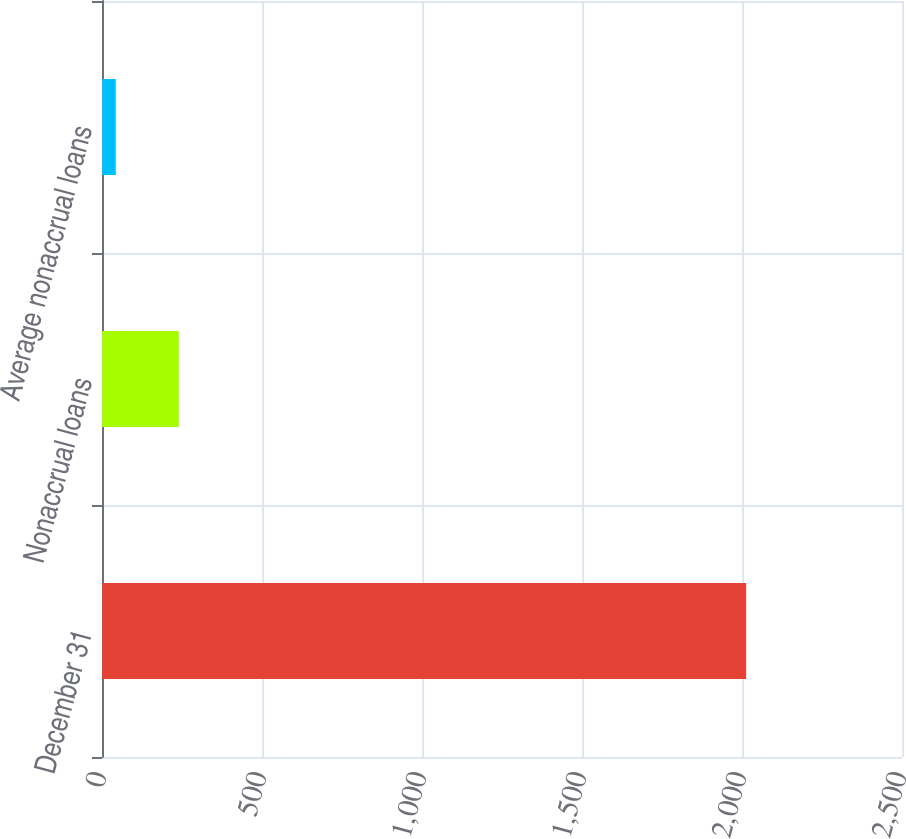Convert chart to OTSL. <chart><loc_0><loc_0><loc_500><loc_500><bar_chart><fcel>December 31<fcel>Nonaccrual loans<fcel>Average nonaccrual loans<nl><fcel>2013<fcel>240<fcel>43<nl></chart> 